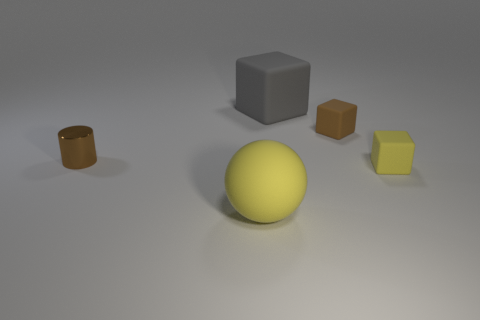Add 2 big spheres. How many objects exist? 7 Subtract all cubes. How many objects are left? 2 Subtract all rubber spheres. Subtract all yellow spheres. How many objects are left? 3 Add 3 gray rubber things. How many gray rubber things are left? 4 Add 5 big gray things. How many big gray things exist? 6 Subtract 1 yellow balls. How many objects are left? 4 